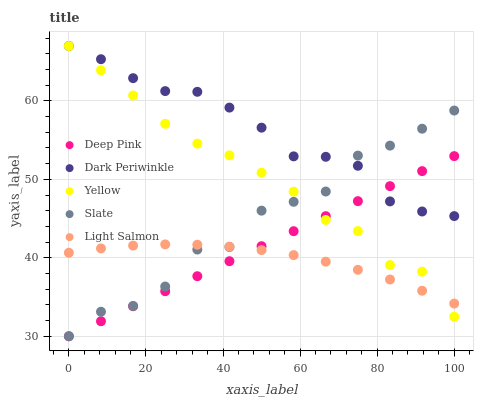Does Light Salmon have the minimum area under the curve?
Answer yes or no. Yes. Does Dark Periwinkle have the maximum area under the curve?
Answer yes or no. Yes. Does Deep Pink have the minimum area under the curve?
Answer yes or no. No. Does Deep Pink have the maximum area under the curve?
Answer yes or no. No. Is Deep Pink the smoothest?
Answer yes or no. Yes. Is Slate the roughest?
Answer yes or no. Yes. Is Dark Periwinkle the smoothest?
Answer yes or no. No. Is Dark Periwinkle the roughest?
Answer yes or no. No. Does Slate have the lowest value?
Answer yes or no. Yes. Does Dark Periwinkle have the lowest value?
Answer yes or no. No. Does Yellow have the highest value?
Answer yes or no. Yes. Does Deep Pink have the highest value?
Answer yes or no. No. Is Light Salmon less than Dark Periwinkle?
Answer yes or no. Yes. Is Dark Periwinkle greater than Light Salmon?
Answer yes or no. Yes. Does Dark Periwinkle intersect Slate?
Answer yes or no. Yes. Is Dark Periwinkle less than Slate?
Answer yes or no. No. Is Dark Periwinkle greater than Slate?
Answer yes or no. No. Does Light Salmon intersect Dark Periwinkle?
Answer yes or no. No. 